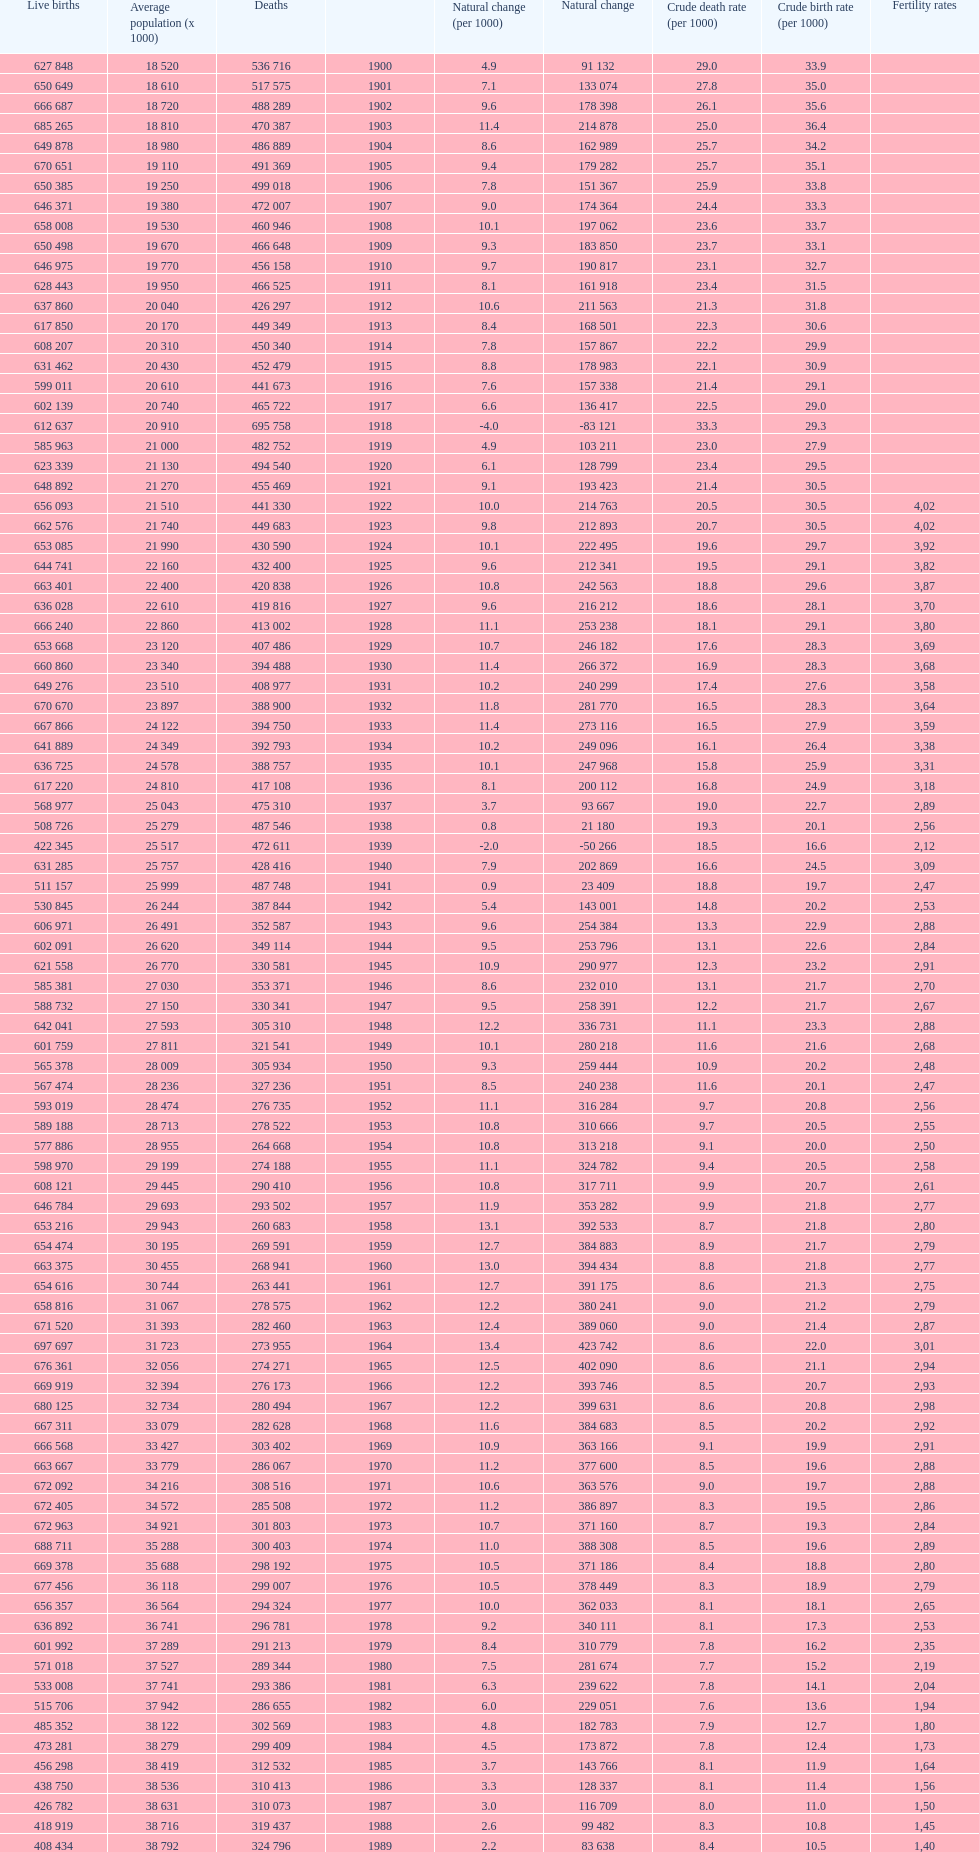Which year has a crude birth rate of 29.1 with a population of 22,860? 1928. 